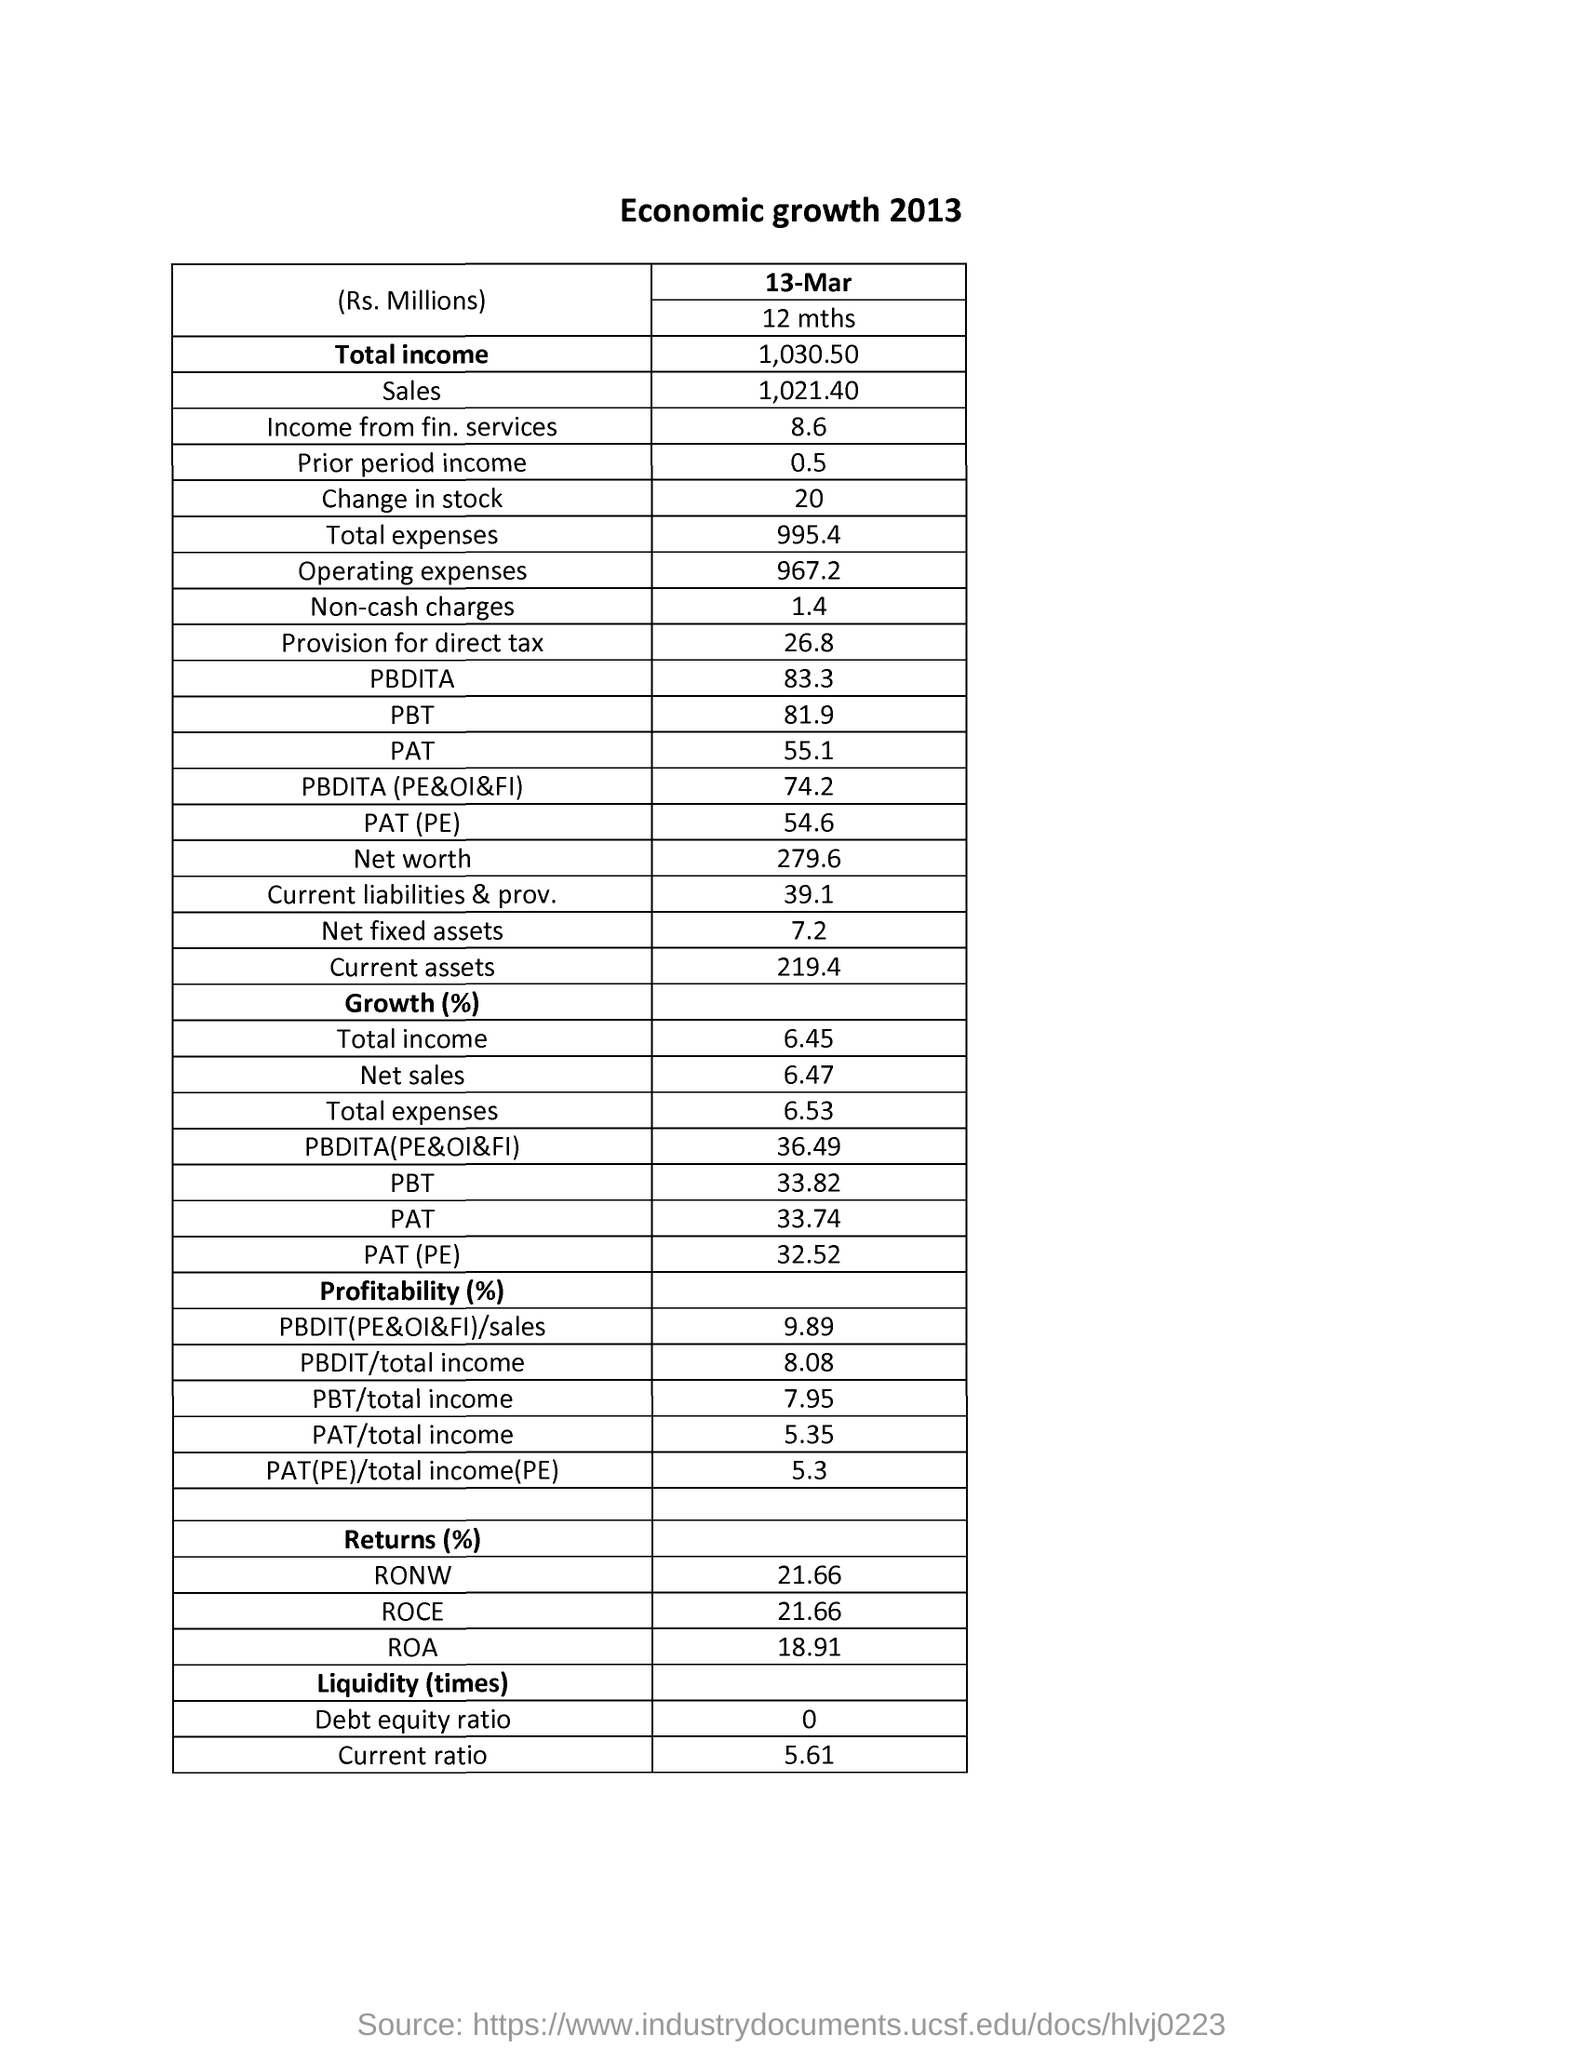How much is the Total Income in Rs?
Ensure brevity in your answer.  1030.50. How much is the income in Rs from fin. services?
Your answer should be compact. 8.6. What is the Return% of ROCE?
Your answer should be very brief. 21.66%. 